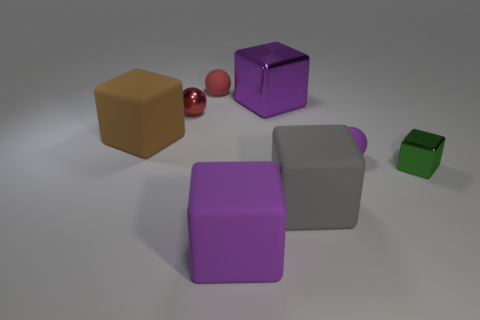Subtract all small cubes. How many cubes are left? 4 Subtract 2 cubes. How many cubes are left? 3 Subtract all blue blocks. Subtract all green balls. How many blocks are left? 5 Add 1 tiny green things. How many objects exist? 9 Subtract all cubes. How many objects are left? 3 Add 2 purple rubber spheres. How many purple rubber spheres are left? 3 Add 3 large purple rubber cubes. How many large purple rubber cubes exist? 4 Subtract 1 gray cubes. How many objects are left? 7 Subtract all small red things. Subtract all red matte objects. How many objects are left? 5 